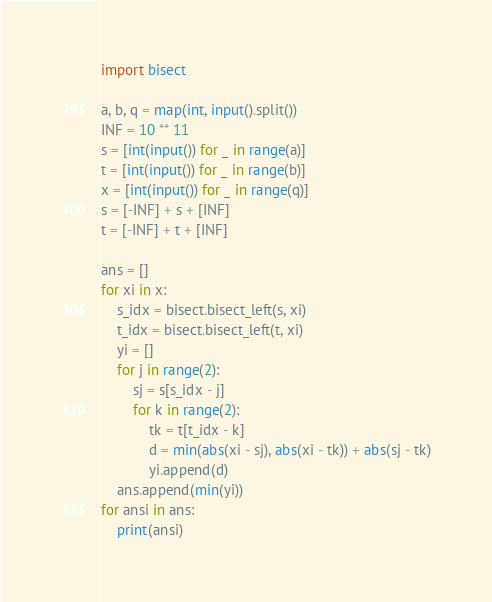<code> <loc_0><loc_0><loc_500><loc_500><_Python_>import bisect

a, b, q = map(int, input().split())
INF = 10 ** 11
s = [int(input()) for _ in range(a)]
t = [int(input()) for _ in range(b)]
x = [int(input()) for _ in range(q)]
s = [-INF] + s + [INF]
t = [-INF] + t + [INF]

ans = []
for xi in x:
    s_idx = bisect.bisect_left(s, xi)
    t_idx = bisect.bisect_left(t, xi)
    yi = []
    for j in range(2):
        sj = s[s_idx - j]
        for k in range(2):
            tk = t[t_idx - k]
            d = min(abs(xi - sj), abs(xi - tk)) + abs(sj - tk)
            yi.append(d)
    ans.append(min(yi))
for ansi in ans:
    print(ansi)
</code> 